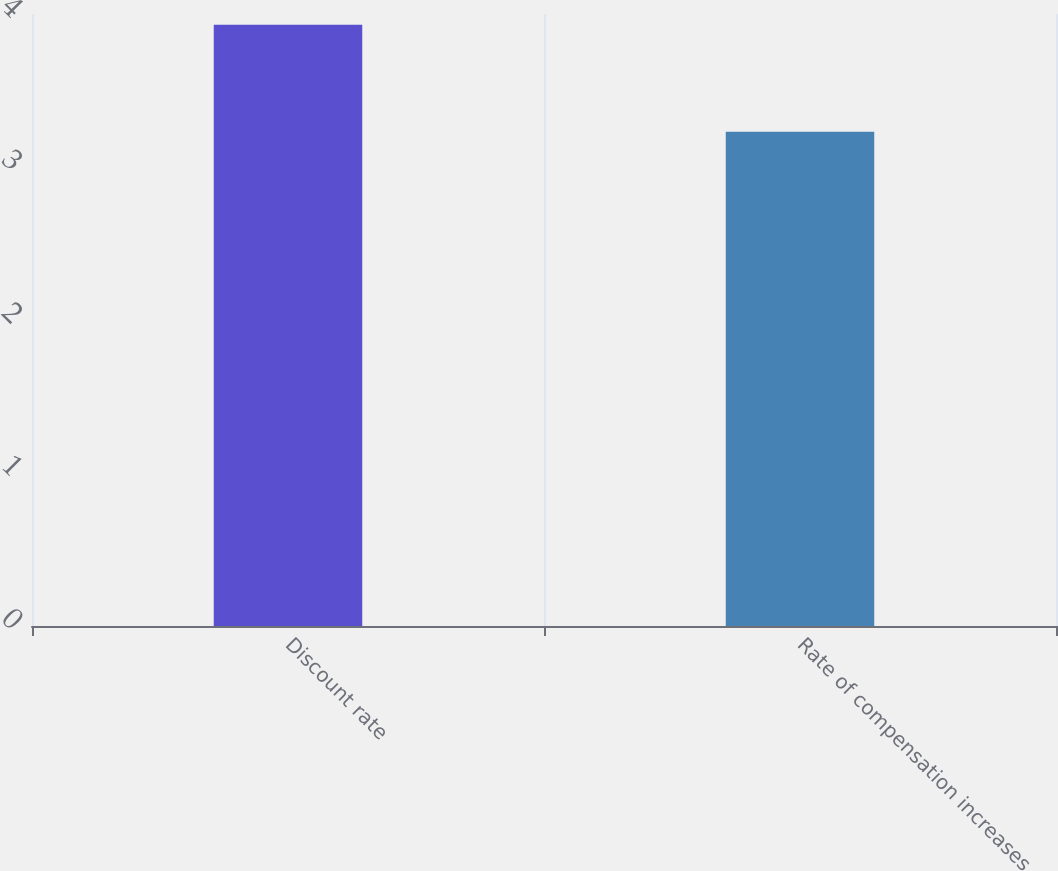<chart> <loc_0><loc_0><loc_500><loc_500><bar_chart><fcel>Discount rate<fcel>Rate of compensation increases<nl><fcel>3.93<fcel>3.23<nl></chart> 